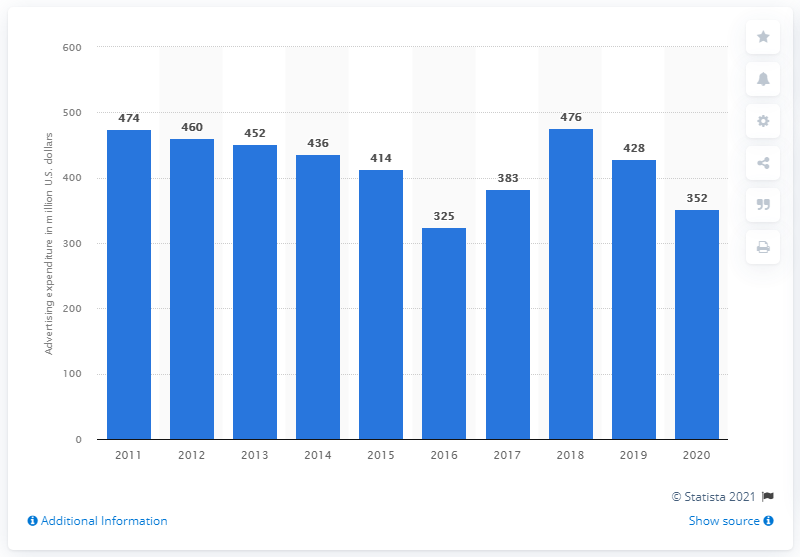Indicate a few pertinent items in this graphic. Limited Brands spent 352 million dollars on its global advertising campaign in 2020. 